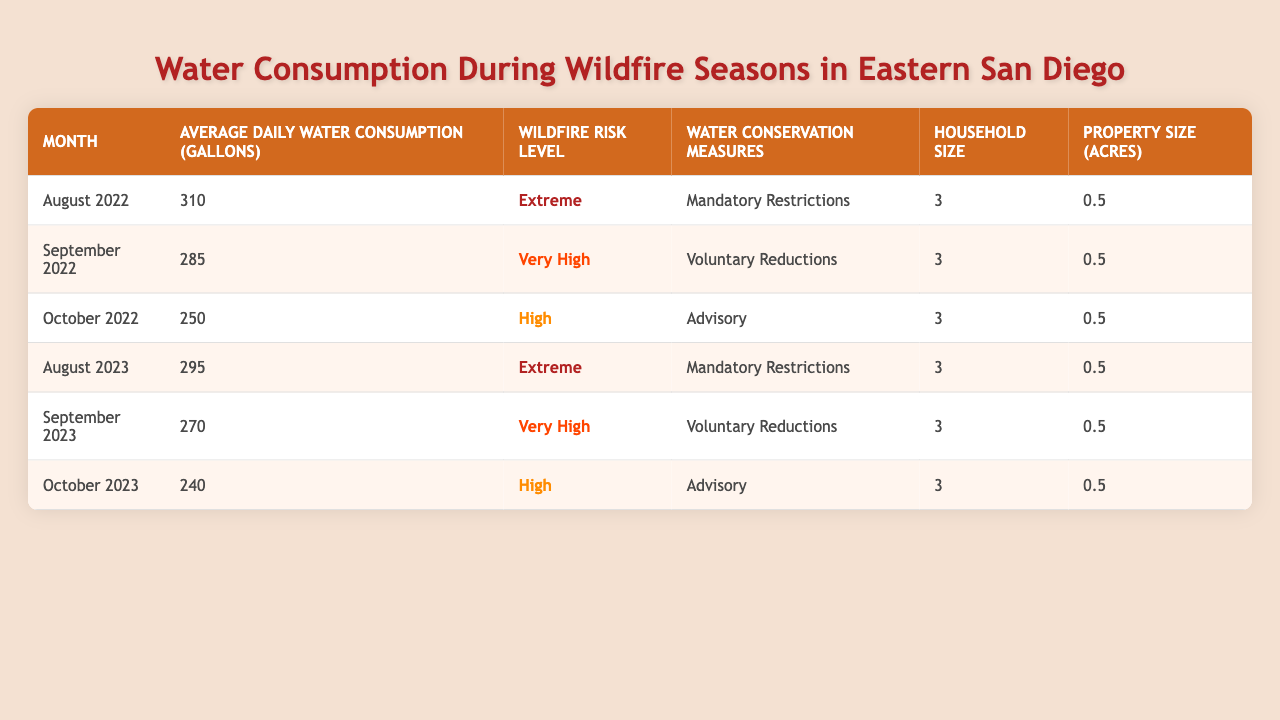What was the average daily water consumption in August 2022? Looking at the table, the "Average Daily Water Consumption (Gallons)" for August 2022 is listed as 310 gallons.
Answer: 310 gallons Which month in 2023 had the lowest average daily water consumption? By comparing the values in the "Average Daily Water Consumption (Gallons)" for the months of August, September, and October 2023, October has the lowest value of 240 gallons.
Answer: October 2023 What wildfire risk level was reported in September 2022? The table shows that the "Wildfire Risk Level" for September 2022 is "Very High".
Answer: Very High Did water consumption increase from October 2022 to August 2023? In October 2022, the average daily water consumption was 250 gallons, while in August 2023, it was 295 gallons. The consumption did increase, from 250 to 295 gallons.
Answer: Yes What is the average daily water consumption during the peak wildfire season months (August to October) in 2022? To find the average, we add the daily water consumption for August (310), September (285), and October (250) which totals 845 gallons. Dividing by 3 gives 845/3 = approximately 281.67 gallons.
Answer: Approximately 281.67 gallons How many gallons were consumed on average from September 2022 to October 2023? We sum the average daily water consumption for September 2022 (285), October 2022 (250), August 2023 (295), September 2023 (270), and October 2023 (240) which gives 285 + 250 + 295 + 270 + 240 = 1340 gallons. Then we divide by 5, leading to an average of 1340/5 = 268 gallons per day.
Answer: 268 gallons Was there a consistent decrease in water consumption from October 2022 to October 2023? Comparing the values, October 2022 had 250 gallons and October 2023 had 240 gallons, which indicates a decrease in water consumption.
Answer: Yes What type of conservation measure was in place during the months with extreme wildfire risk? Looking at the table, both August 2022 and August 2023 had "Mandatory Restrictions" as the water conservation measure during "Extreme" risk levels.
Answer: Mandatory Restrictions How does the household size stay constant across the dataset? The table lists the household size consistently as 3 for each month and year, reflecting no change in household size across the given data.
Answer: It's constant at 3 